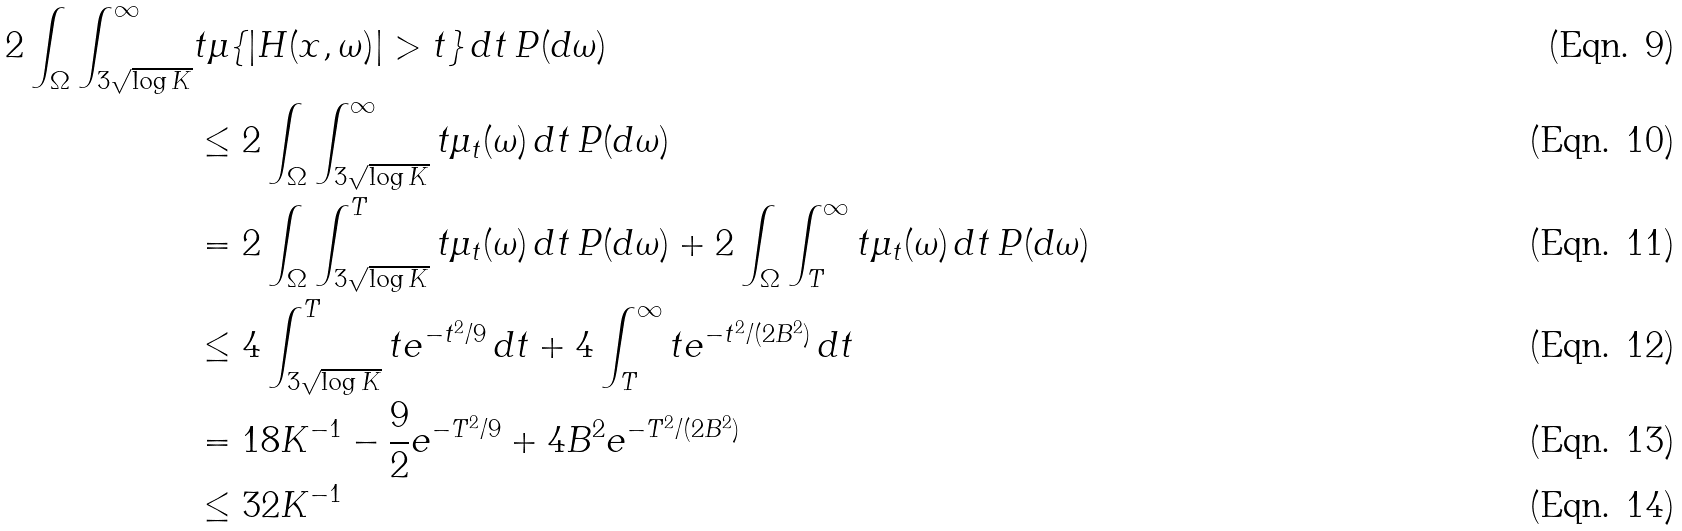Convert formula to latex. <formula><loc_0><loc_0><loc_500><loc_500>2 \int _ { \Omega } \int _ { 3 \sqrt { \log K } } ^ { \infty } & t \mu \{ | H ( x , \omega ) | > t \} \, d t \, P ( d \omega ) \\ & \leq 2 \int _ { \Omega } \int _ { 3 \sqrt { \log K } } ^ { \infty } t \mu _ { t } ( \omega ) \, d t \, P ( d \omega ) \\ & = 2 \int _ { \Omega } \int _ { 3 \sqrt { \log K } } ^ { T } t \mu _ { t } ( \omega ) \, d t \, P ( d \omega ) + 2 \int _ { \Omega } \int _ { T } ^ { \infty } t \mu _ { t } ( \omega ) \, d t \, P ( d \omega ) \\ & \leq 4 \int _ { 3 \sqrt { \log K } } ^ { T } t e ^ { - t ^ { 2 } / 9 } \, d t + 4 \int _ { T } ^ { \infty } t e ^ { - t ^ { 2 } / ( 2 B ^ { 2 } ) } \, d t \\ & = 1 8 K ^ { - 1 } - \frac { 9 } { 2 } e ^ { - T ^ { 2 } / 9 } + 4 B ^ { 2 } e ^ { - T ^ { 2 } / ( 2 B ^ { 2 } ) } \\ & \leq 3 2 K ^ { - 1 }</formula> 